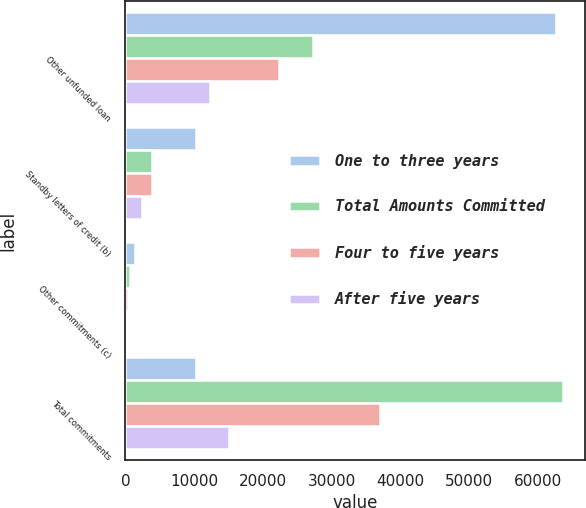<chart> <loc_0><loc_0><loc_500><loc_500><stacked_bar_chart><ecel><fcel>Other unfunded loan<fcel>Standby letters of credit (b)<fcel>Other commitments (c)<fcel>Total commitments<nl><fcel>One to three years<fcel>62665<fcel>10317<fcel>1408<fcel>10317<nl><fcel>Total Amounts Committed<fcel>27260<fcel>3855<fcel>595<fcel>63601<nl><fcel>Four to five years<fcel>22317<fcel>3916<fcel>390<fcel>36955<nl><fcel>After five years<fcel>12358<fcel>2352<fcel>302<fcel>15012<nl></chart> 